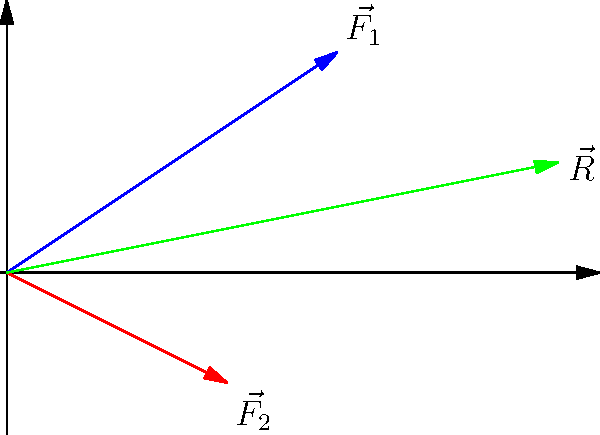In your minimalist game, you have an object affected by two force vectors: $\vec{F_1} = (3, 2)$ and $\vec{F_2} = (2, -1)$. What is the resultant force vector $\vec{R}$ acting on the object? To find the resultant vector $\vec{R}$ when two force vectors $\vec{F_1}$ and $\vec{F_2}$ are applied to a game object, we need to add these vectors:

1. Identify the components of each vector:
   $\vec{F_1} = (3, 2)$
   $\vec{F_2} = (2, -1)$

2. Add the x-components:
   $R_x = F_{1x} + F_{2x} = 3 + 2 = 5$

3. Add the y-components:
   $R_y = F_{1y} + F_{2y} = 2 + (-1) = 1$

4. The resultant vector $\vec{R}$ is the combination of these components:
   $\vec{R} = (R_x, R_y) = (5, 1)$

This vector addition can be visualized as completing a parallelogram formed by the two force vectors, where the resultant is the diagonal of this parallelogram.
Answer: $\vec{R} = (5, 1)$ 